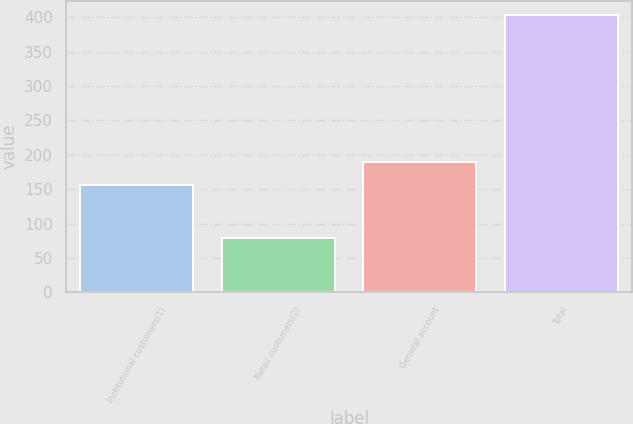Convert chart. <chart><loc_0><loc_0><loc_500><loc_500><bar_chart><fcel>Institutional customers(1)<fcel>Retail customers(2)<fcel>General account<fcel>Total<nl><fcel>156.8<fcel>79<fcel>189.24<fcel>403.4<nl></chart> 